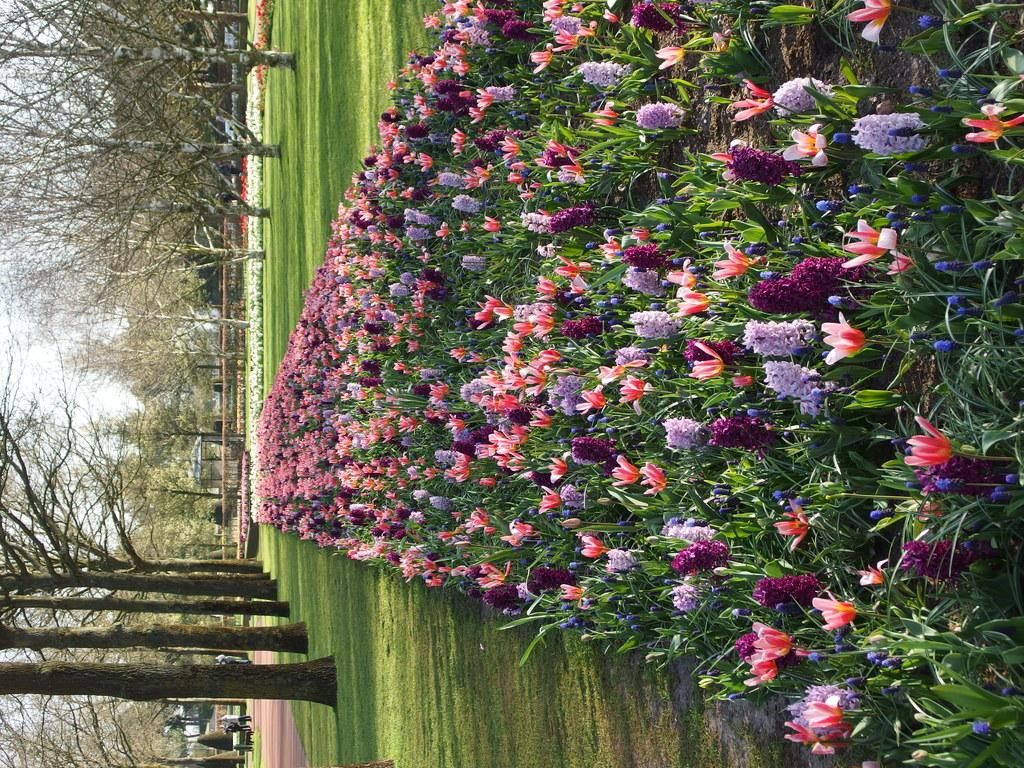What is the main subject of the image? The main subject of the image is flowers and plants. Where are the flowers and plants located in the image? There are flowers and plants in the center of the image, on the right side of the image, and on the left side of the image. What types of vegetation can be seen on the left side of the image? There are trees, flowers, and grass on the left side of the image. Can you tell me how many pieces of quartz are visible in the image? There is no quartz present in the image; it features flowers, plants, and trees. Is there a spy observing the scene in the image? There is no indication of a spy or any human presence in the image, as it focuses on natural elements like flowers, plants, and trees. 